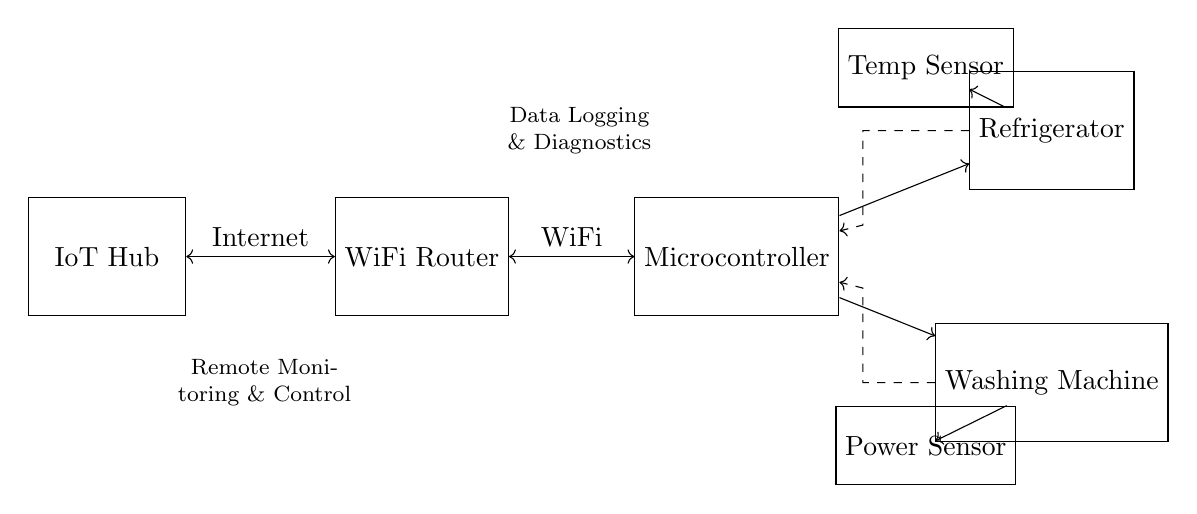What is the function of the IoT Hub? The IoT Hub serves as the central point for connecting the appliances to the internet, facilitating remote diagnostics and data logging.
Answer: Central connection What type of appliances are included in the circuit? The circuit includes a refrigerator and a washing machine, as indicated by the labeled components.
Answer: Refrigerator, washing machine How does the microcontroller connect to the appliances? The microcontroller is directly connected to both the refrigerator and the washing machine with arrows indicating control signals flow.
Answer: Directly What is the role of the power sensor? The power sensor monitors the power consumption of the washing machine, as shown by its specific connection to that appliance.
Answer: Power consumption monitoring What type of data logging is indicated in the diagram? The diagram indicates data logging related to diagnostics of the connected appliances, as mentioned by the label on the data flow line.
Answer: Diagnostics data logging Which device connects the IoT Hub to the internet? The WiFi Router is the device that connects the IoT Hub to the internet, as shown by the connection arrow between them.
Answer: WiFi Router What kind of communication occurs between the appliances and the microcontroller? Communication occurs through one-way arrows indicating control and data flow from the appliances to the microcontroller for diagnostics.
Answer: One-way control signals 